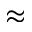Convert formula to latex. <formula><loc_0><loc_0><loc_500><loc_500>\approx</formula> 